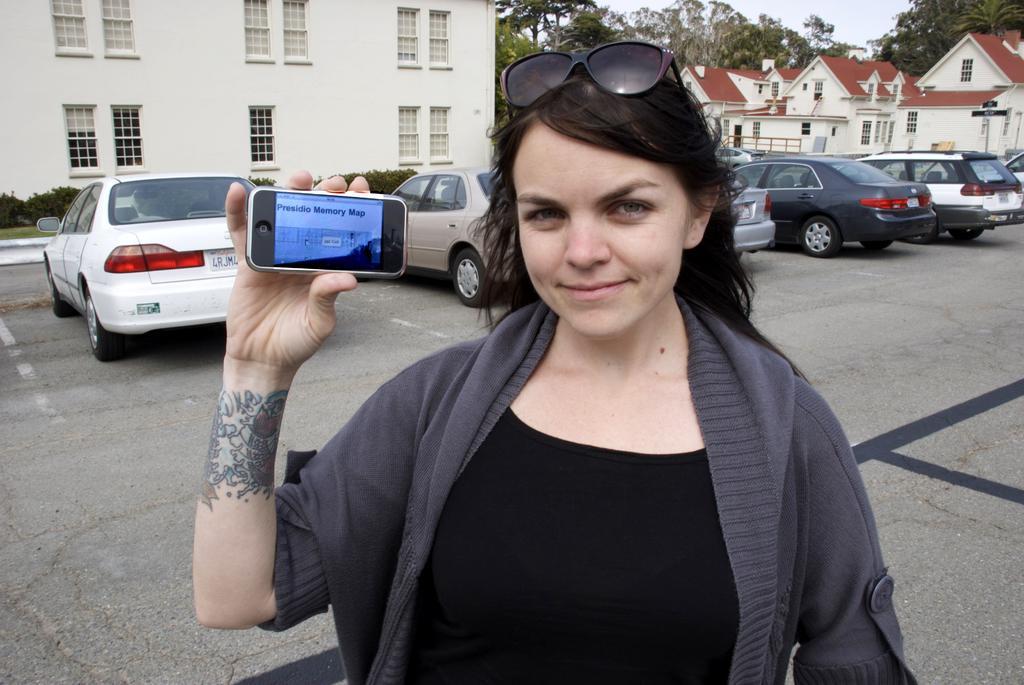In one or two sentences, can you explain what this image depicts? This woman wore jacket, goggles and holding a mobile. This is a white building with windows. Far there are number of trees. This is a house with red roof top. There are number of vehicles on road. These are plants. 